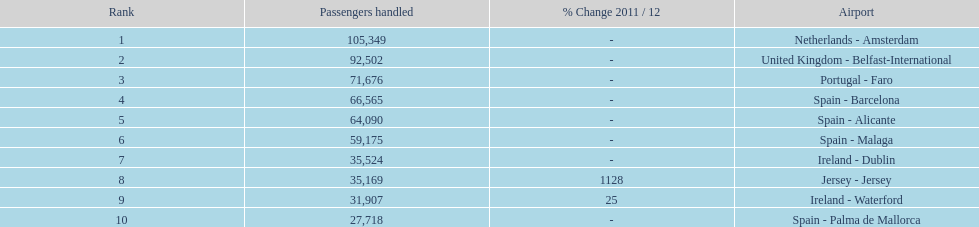Where is the most popular destination for passengers leaving london southend airport? Netherlands - Amsterdam. Could you parse the entire table as a dict? {'header': ['Rank', 'Passengers handled', '% Change 2011 / 12', 'Airport'], 'rows': [['1', '105,349', '-', 'Netherlands - Amsterdam'], ['2', '92,502', '-', 'United Kingdom - Belfast-International'], ['3', '71,676', '-', 'Portugal - Faro'], ['4', '66,565', '-', 'Spain - Barcelona'], ['5', '64,090', '-', 'Spain - Alicante'], ['6', '59,175', '-', 'Spain - Malaga'], ['7', '35,524', '-', 'Ireland - Dublin'], ['8', '35,169', '1128', 'Jersey - Jersey'], ['9', '31,907', '25', 'Ireland - Waterford'], ['10', '27,718', '-', 'Spain - Palma de Mallorca']]} 